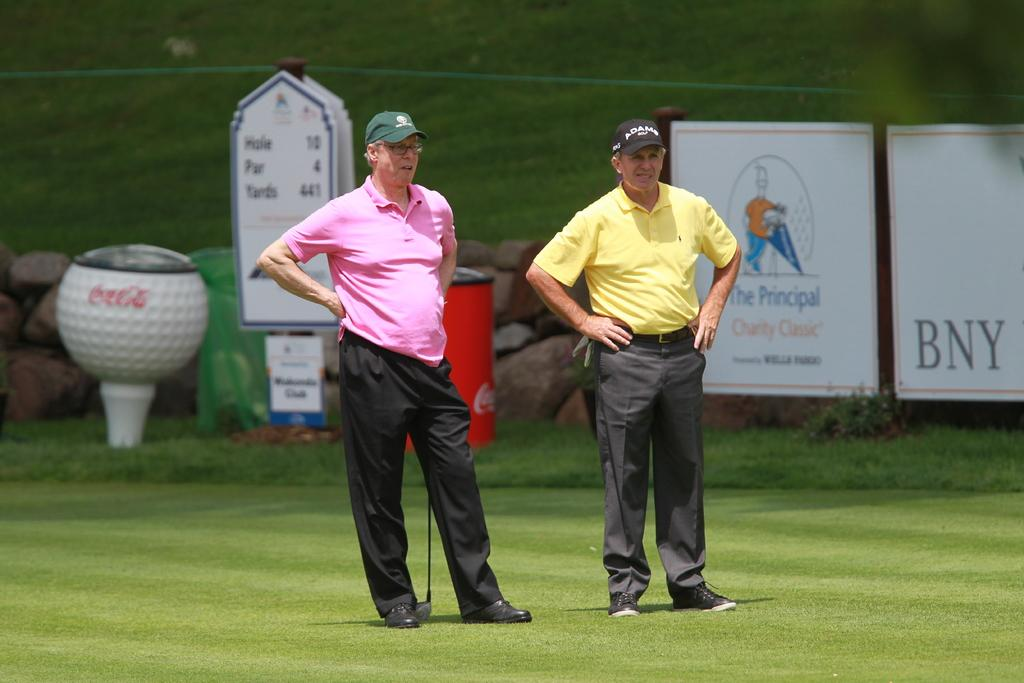<image>
Relay a brief, clear account of the picture shown. Two men playing golf in front of a poster which reads BNY 